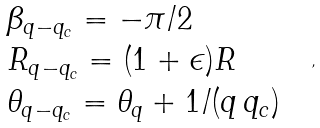<formula> <loc_0><loc_0><loc_500><loc_500>\begin{array} { l } \beta _ { { q } - { q } _ { c } } = - \pi / 2 \\ R _ { { q } - { q } _ { c } } = ( 1 + \epsilon ) R \\ \theta _ { { q } - { q } _ { c } } = \theta _ { q } + 1 / ( q \, q _ { c } ) \end{array} \ \ ,</formula> 